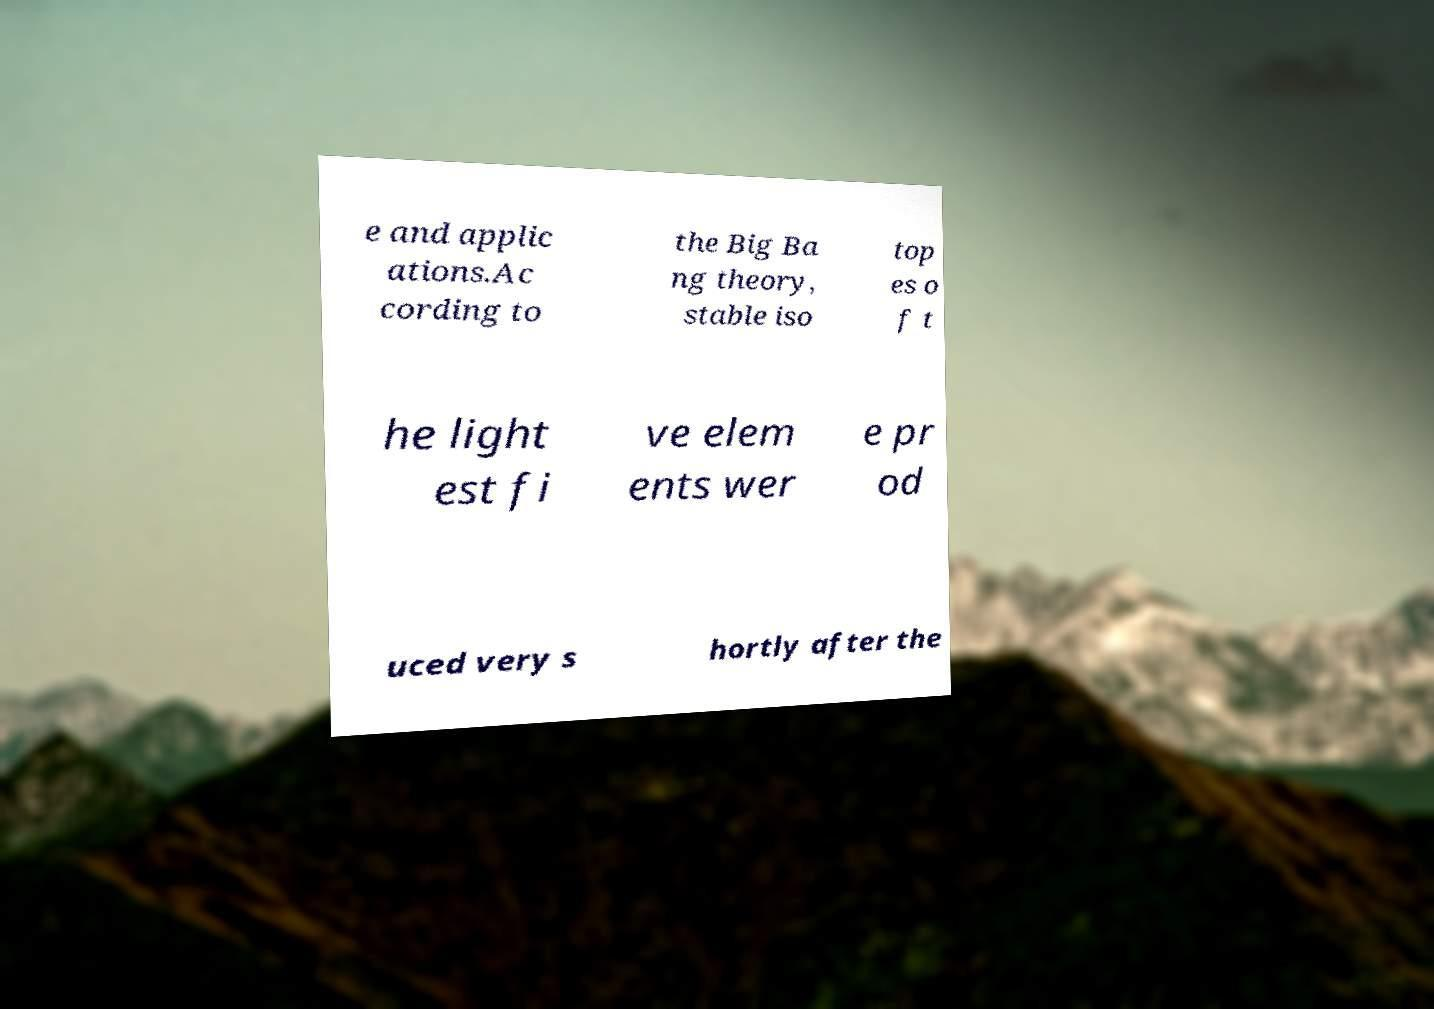I need the written content from this picture converted into text. Can you do that? e and applic ations.Ac cording to the Big Ba ng theory, stable iso top es o f t he light est fi ve elem ents wer e pr od uced very s hortly after the 